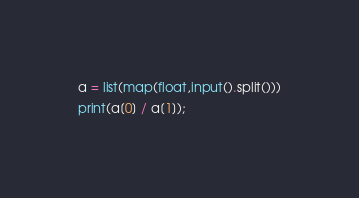Convert code to text. <code><loc_0><loc_0><loc_500><loc_500><_Python_>a = list(map(float,input().split()))
print(a[0] / a[1]);</code> 